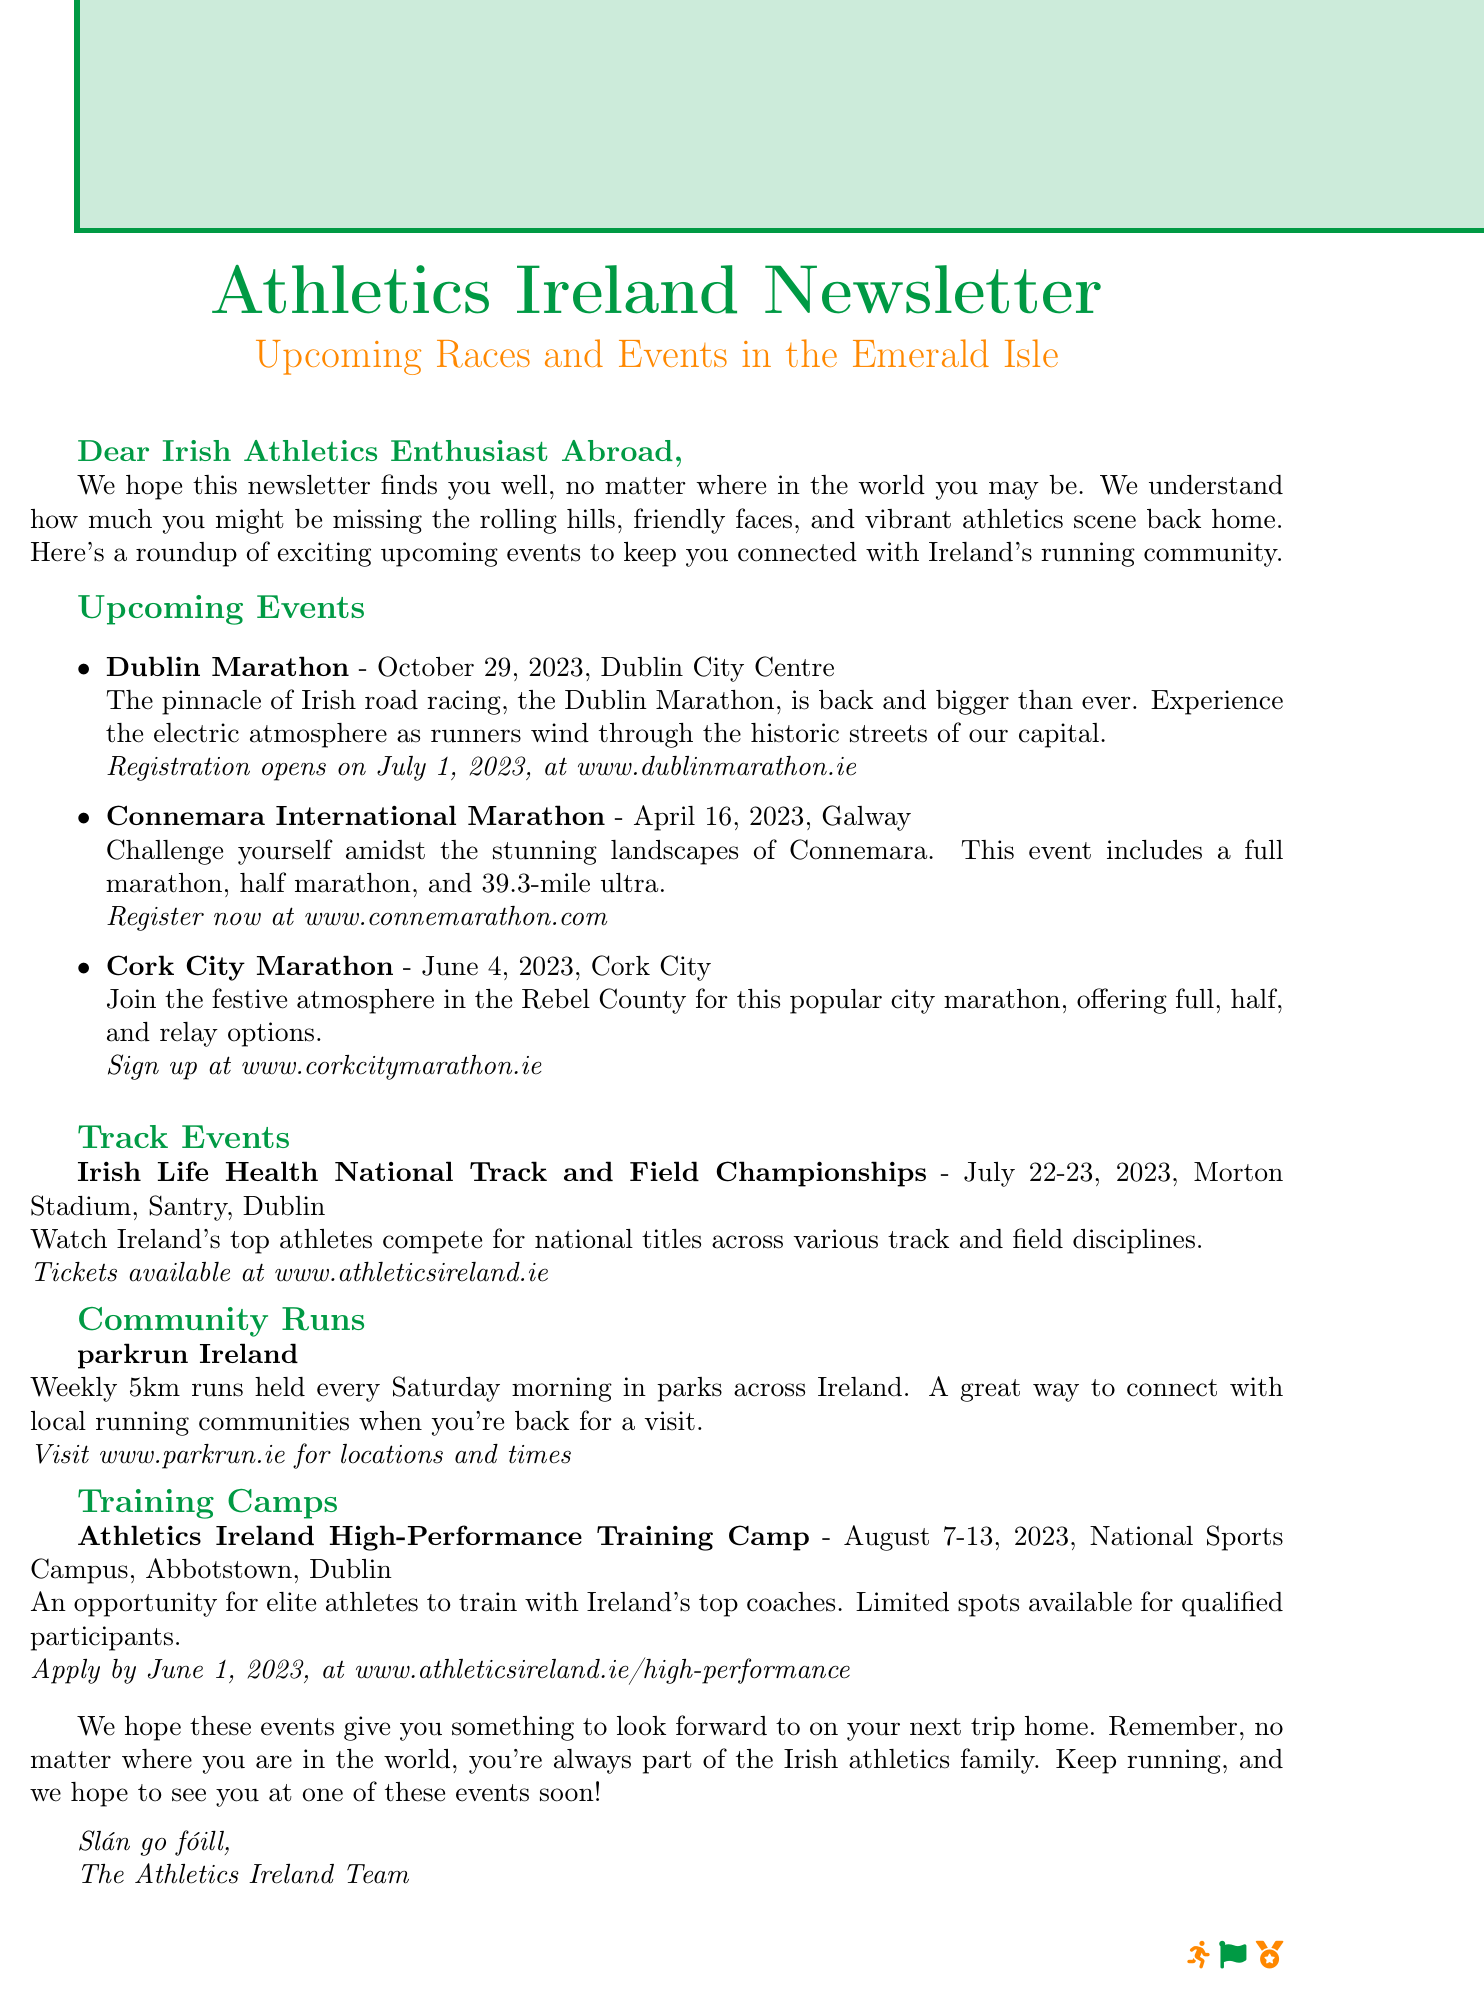What is the subject of the newsletter? The subject of the newsletter is mentioned at the beginning of the document.
Answer: Athletics Ireland Newsletter: Upcoming Races and Events in the Emerald Isle When does the Dublin Marathon take place? The date of the Dublin Marathon is specified in the event details.
Answer: October 29, 2023 Where is the Cork City Marathon located? The specific location of the Cork City Marathon is given in the event section.
Answer: Cork City What is the registration date for the Connemara International Marathon? The registration information for the Connemara International Marathon is provided above the event details.
Answer: Register now What type of event is the Irish Life Health National Track and Field Championships? The document specifies the kind of event taking place at this championship.
Answer: Track and field championships Where can you find community runs in Ireland? The document provides a website where information about community runs can be accessed.
Answer: www.parkrun.ie What is the starting date for the Athletics Ireland High-Performance Training Camp? The date for the training camp is listed in the training camps section.
Answer: August 7, 2023 What is the purpose of the Dublin Marathon? The description of the Dublin Marathon indicates its significance.
Answer: Pinnacle of Irish road racing Who is the audience of this newsletter? The greeting at the top specifies who the newsletter is aimed at.
Answer: Irish Athletics Enthusiast Abroad 